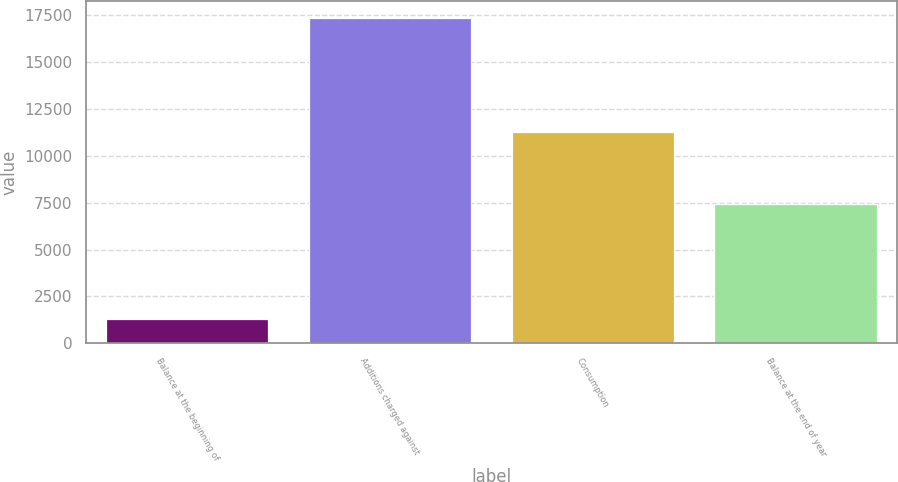<chart> <loc_0><loc_0><loc_500><loc_500><bar_chart><fcel>Balance at the beginning of<fcel>Additions charged against<fcel>Consumption<fcel>Balance at the end of year<nl><fcel>1317<fcel>17371<fcel>11265<fcel>7423<nl></chart> 